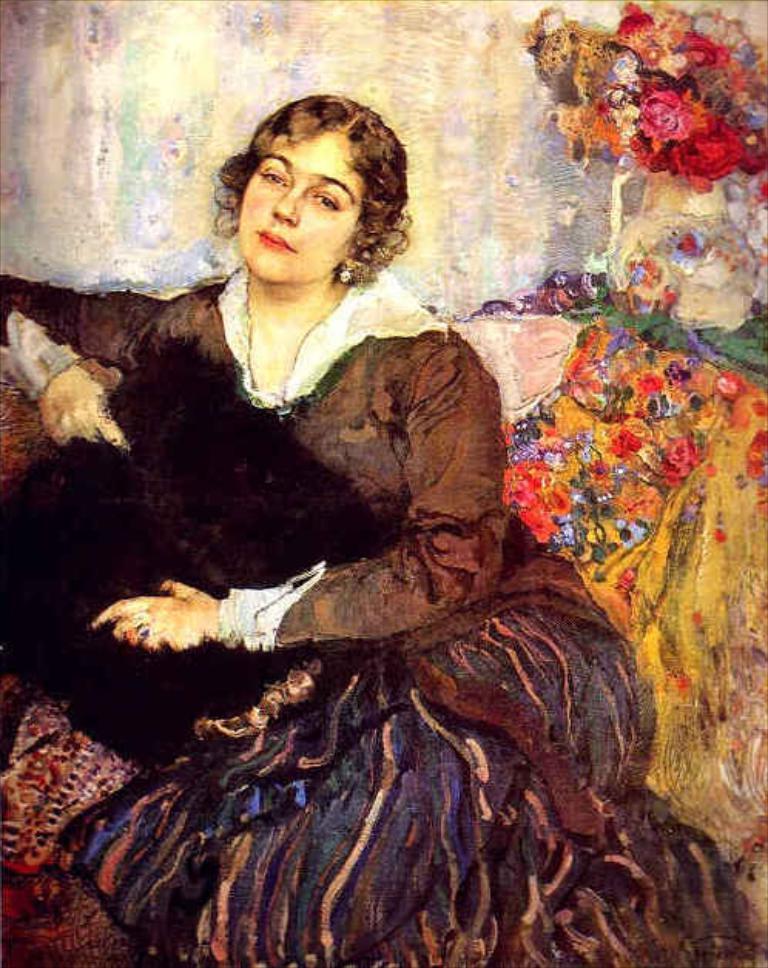Could you give a brief overview of what you see in this image? In this image I can see the painting of the person and I can see the person wearing the brown and blue color dress and also holding the black color object. To the side I can see the colorful flowers. 